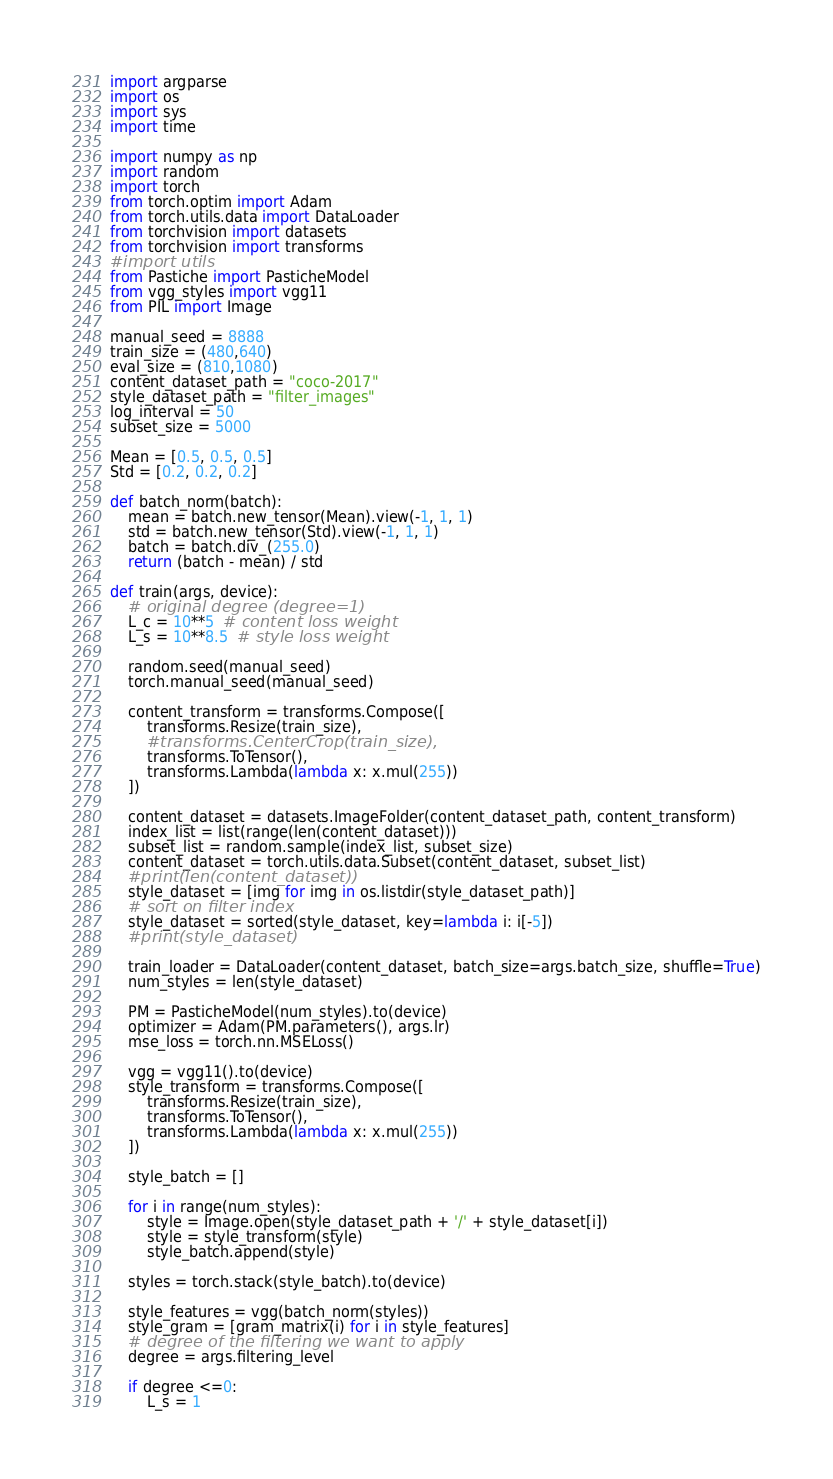<code> <loc_0><loc_0><loc_500><loc_500><_Python_>import argparse
import os
import sys
import time

import numpy as np
import random
import torch
from torch.optim import Adam
from torch.utils.data import DataLoader
from torchvision import datasets
from torchvision import transforms
#import utils
from Pastiche import PasticheModel
from vgg_styles import vgg11
from PIL import Image

manual_seed = 8888
train_size = (480,640)
eval_size = (810,1080)
content_dataset_path = "coco-2017"
style_dataset_path = "filter_images"
log_interval = 50
subset_size = 5000

Mean = [0.5, 0.5, 0.5]
Std = [0.2, 0.2, 0.2]

def batch_norm(batch):
    mean = batch.new_tensor(Mean).view(-1, 1, 1)
    std = batch.new_tensor(Std).view(-1, 1, 1)
    batch = batch.div_(255.0)
    return (batch - mean) / std

def train(args, device):
    # original degree (degree=1)
    L_c = 10**5  # content loss weight
    L_s = 10**8.5  # style loss weight

    random.seed(manual_seed)
    torch.manual_seed(manual_seed)

    content_transform = transforms.Compose([
        transforms.Resize(train_size),
        #transforms.CenterCrop(train_size),
        transforms.ToTensor(),
        transforms.Lambda(lambda x: x.mul(255))
    ])

    content_dataset = datasets.ImageFolder(content_dataset_path, content_transform)
    index_list = list(range(len(content_dataset)))
    subset_list = random.sample(index_list, subset_size)
    content_dataset = torch.utils.data.Subset(content_dataset, subset_list)
    #print(len(content_dataset))
    style_dataset = [img for img in os.listdir(style_dataset_path)]
    # sort on filter index
    style_dataset = sorted(style_dataset, key=lambda i: i[-5])
    #print(style_dataset)

    train_loader = DataLoader(content_dataset, batch_size=args.batch_size, shuffle=True)
    num_styles = len(style_dataset)

    PM = PasticheModel(num_styles).to(device)
    optimizer = Adam(PM.parameters(), args.lr)
    mse_loss = torch.nn.MSELoss()

    vgg = vgg11().to(device)
    style_transform = transforms.Compose([
        transforms.Resize(train_size),
        transforms.ToTensor(),
        transforms.Lambda(lambda x: x.mul(255))
    ])

    style_batch = []

    for i in range(num_styles):
        style = Image.open(style_dataset_path + '/' + style_dataset[i])
        style = style_transform(style)
        style_batch.append(style)

    styles = torch.stack(style_batch).to(device)

    style_features = vgg(batch_norm(styles))
    style_gram = [gram_matrix(i) for i in style_features]
    # degree of the filtering we want to apply
    degree = args.filtering_level

    if degree <=0:
        L_s = 1</code> 